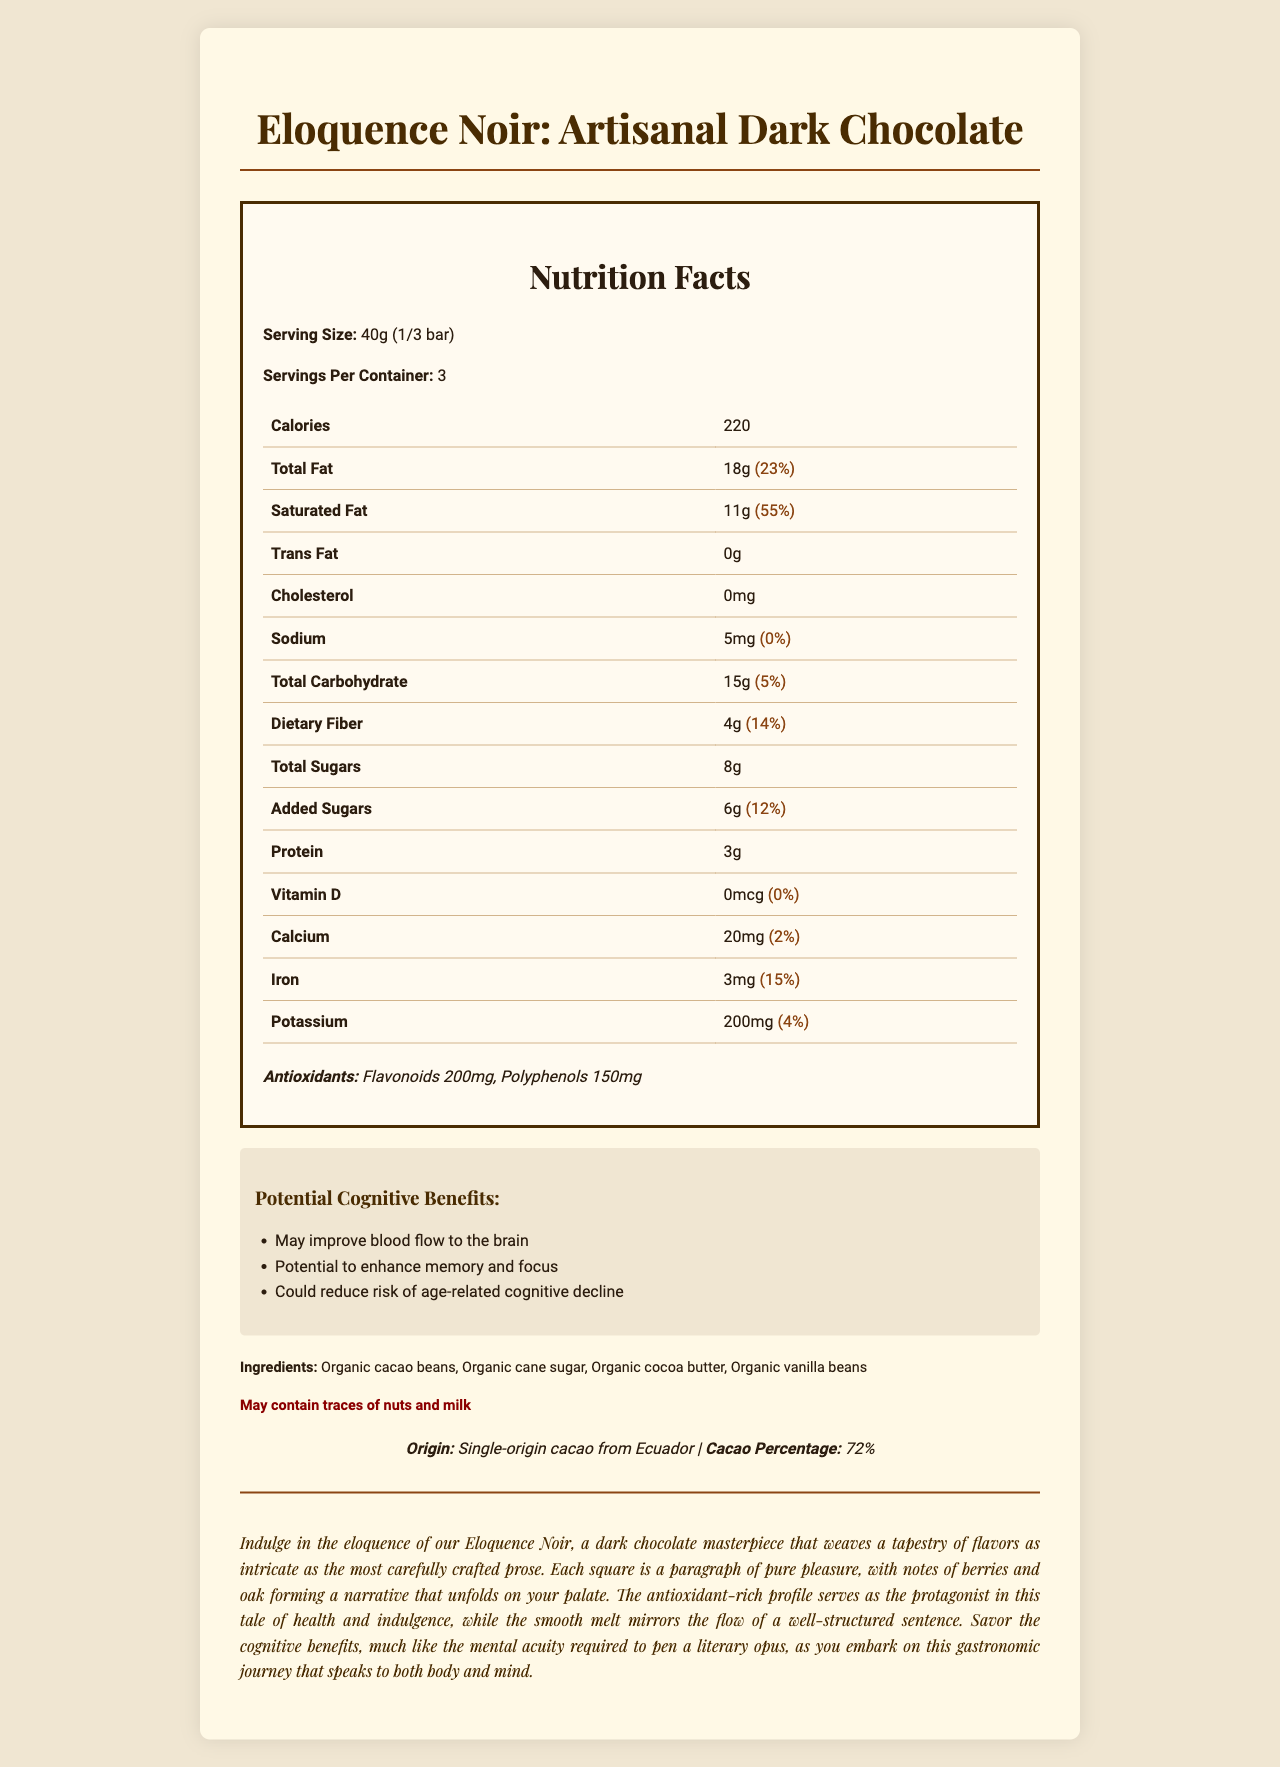what is the serving size? The document states the serving size as 40g, which is equivalent to 1/3 of the bar.
Answer: 40g (1/3 bar) how many servings are there per container? The document mentions there are 3 servings per container.
Answer: 3 how much saturated fat does one serving contain? The saturated fat content per serving is listed as 11g.
Answer: 11g what is the amount of dietary fiber per serving? The document lists the dietary fiber content as 4g per serving.
Answer: 4g what is the cacao percentage in the chocolate bar? The document specifies that the cacao percentage is 72%.
Answer: 72% which of the following is NOT an ingredient in the chocolate bar?
1. Organic cacao beans
2. Organic cane sugar
3. Organic vanilla beans
4. Milk chocolate The ingredients listed in the document are organic cacao beans, organic cane sugar, organic cocoa butter, and organic vanilla beans. Milk chocolate is not on the list.
Answer: 4 how many grams of polyphenols are in the chocolate bar per serving?
A. 50g
B. 75g
C. 150g
D. 200g The antioxidants section of the document lists polyphenols content as 150mg per serving.
Answer: C is the chocolate bar free from trans fat? The document lists the trans fat content as 0g, indicating that it is trans fat-free.
Answer: Yes does the chocolate bar potentially enhance memory and focus? The document mentions that one of the cognitive benefits is the potential to enhance memory and focus.
Answer: Yes summarize the main idea of this document. The document is a complete nutritional profile and marketing description of the Eloquence Noir artisanal dark chocolate bar, designed to inform consumers about its health benefits and ingredient quality.
Answer: The document provides detailed nutritional information about Eloquence Noir: Artisanal Dark Chocolate, highlighting its high antioxidant content and potential cognitive benefits. It lists serving size, calories, macronutrient and micronutrient values, ingredients, allergen information, and describes the origin and cacao percentage. Additionally, it includes a poetic description of the chocolate bar, emphasizing its intricate flavors and health benefits. what is the total fat content per serving? The total fat content per serving is listed as 18g.
Answer: 18g how many grams of added sugars are in one serving? The document states that there are 6g of added sugars per serving.
Answer: 6g from which country does the single-origin cacao come? The document specifies that the single-origin cacao is from Ecuador.
Answer: Ecuador is there any information on the shelf life of the chocolate bar? The document does not provide any details regarding the shelf life of the chocolate bar.
Answer: Not enough information what are the potential cognitive benefits of the chocolate bar? The cognitive benefits section of the document lists these three potential benefits: improved blood flow to the brain, enhanced memory and focus, and reduced risk of age-related cognitive decline.
Answer: May improve blood flow to the brain, potential to enhance memory and focus, and could reduce risk of age-related cognitive decline 